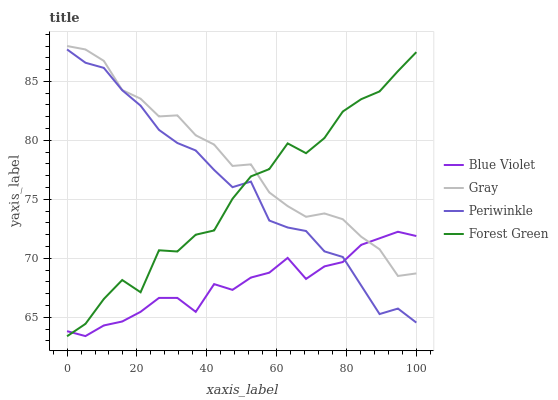Does Blue Violet have the minimum area under the curve?
Answer yes or no. Yes. Does Gray have the maximum area under the curve?
Answer yes or no. Yes. Does Forest Green have the minimum area under the curve?
Answer yes or no. No. Does Forest Green have the maximum area under the curve?
Answer yes or no. No. Is Gray the smoothest?
Answer yes or no. Yes. Is Forest Green the roughest?
Answer yes or no. Yes. Is Periwinkle the smoothest?
Answer yes or no. No. Is Periwinkle the roughest?
Answer yes or no. No. Does Forest Green have the lowest value?
Answer yes or no. Yes. Does Periwinkle have the lowest value?
Answer yes or no. No. Does Gray have the highest value?
Answer yes or no. Yes. Does Forest Green have the highest value?
Answer yes or no. No. Is Periwinkle less than Gray?
Answer yes or no. Yes. Is Gray greater than Periwinkle?
Answer yes or no. Yes. Does Periwinkle intersect Forest Green?
Answer yes or no. Yes. Is Periwinkle less than Forest Green?
Answer yes or no. No. Is Periwinkle greater than Forest Green?
Answer yes or no. No. Does Periwinkle intersect Gray?
Answer yes or no. No. 